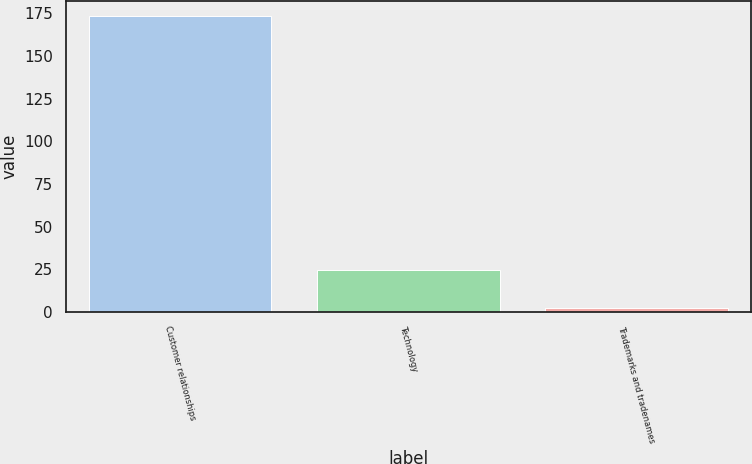Convert chart. <chart><loc_0><loc_0><loc_500><loc_500><bar_chart><fcel>Customer relationships<fcel>Technology<fcel>Trademarks and tradenames<nl><fcel>173.7<fcel>24.4<fcel>2<nl></chart> 